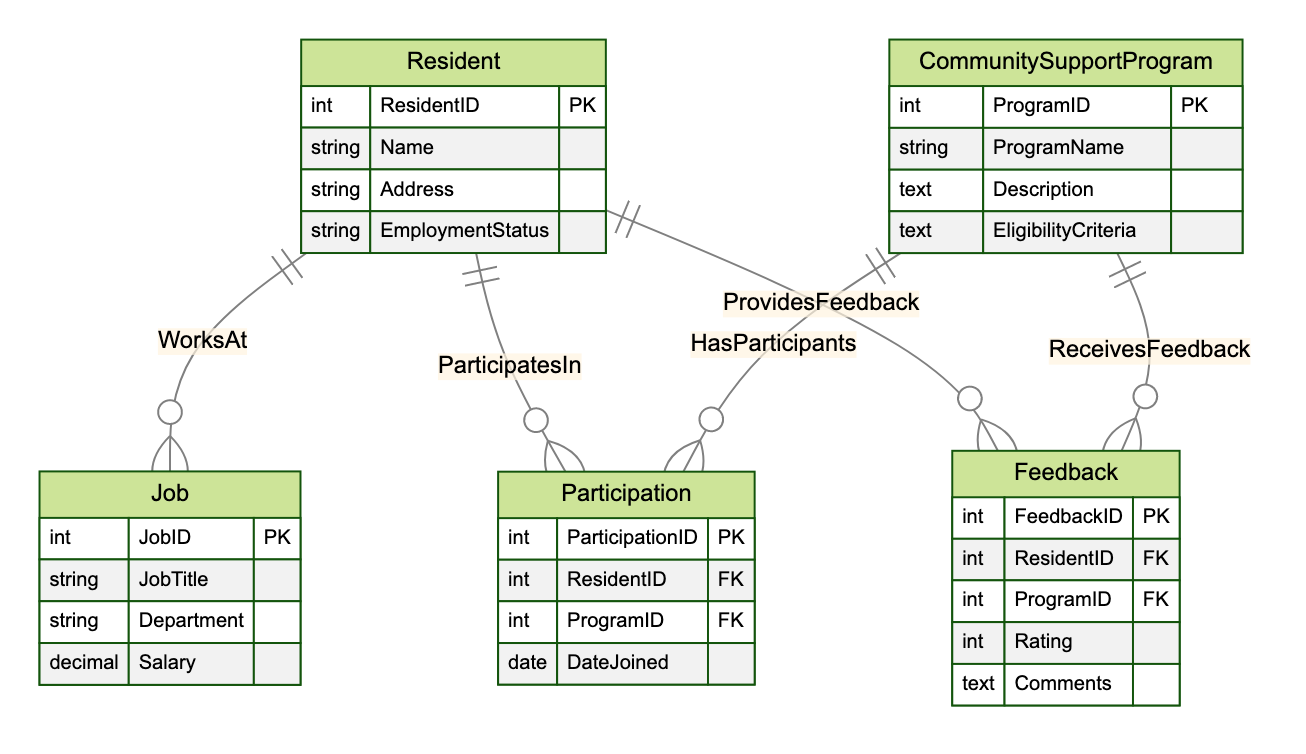What is the primary key of the Resident entity? The diagram indicates that the primary key for the Resident entity is ResidentID, which uniquely identifies each resident in the system.
Answer: ResidentID How many attributes does the CommunitySupportProgram entity have? By examining the attributes listed under the CommunitySupportProgram entity, we see there are four attributes: ProgramID, ProgramName, Description, and EligibilityCriteria.
Answer: 4 What type of relationship exists between Resident and Job? The relationship between Resident and Job is labeled as "WorksAt," which is defined as a OneToMany relationship, meaning one resident can have multiple jobs.
Answer: OneToMany What foreign keys are present in the Feedback entity? The Feedback entity has two foreign keys: ResidentID and ProgramID, which reference the Resident and CommunitySupportProgram entities, respectively.
Answer: ResidentID, ProgramID How many distinct entities are in the diagram? The diagram includes five entities: Resident, Job, CommunitySupportProgram, Participation, and Feedback. By counting each entity, we find there are five.
Answer: 5 Which entity can a resident provide feedback to? According to the relationships in the diagram, residents can provide feedback to the CommunitySupportProgram entity through the Feedback relationship.
Answer: CommunitySupportProgram What is the relationship type between Resident and Participation? The diagram shows that the relationship between Resident and Participation is ManyToMany, indicating that residents can participate in multiple community support programs, and each program can have multiple residents.
Answer: ManyToMany What attribute in the Participation entity indicates when a resident joined a program? The Participation entity contains an attribute named DateJoined, which records the date when a resident joined a community support program.
Answer: DateJoined How does a resident participate in community support programs? Residents participate in community support programs through the Participation entity, which acts as a junction between the Resident and CommunitySupportProgram entities, allowing for ManyToMany relationships.
Answer: Through Participation Which entity receives feedback from residents? The CommunitySupportProgram entity is the one that receives feedback from residents, as indicated by the ProvidesFeedback relationship that connects them through the Feedback entity.
Answer: CommunitySupportProgram 